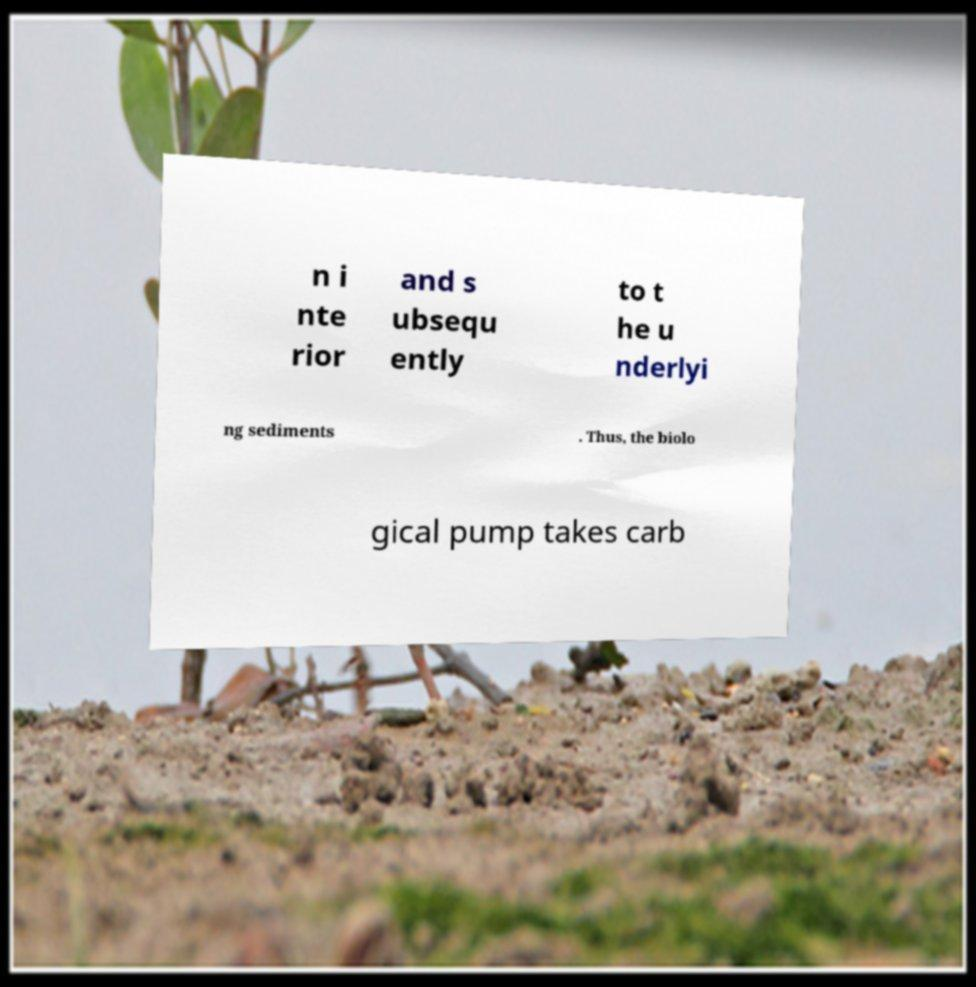Please read and relay the text visible in this image. What does it say? n i nte rior and s ubsequ ently to t he u nderlyi ng sediments . Thus, the biolo gical pump takes carb 